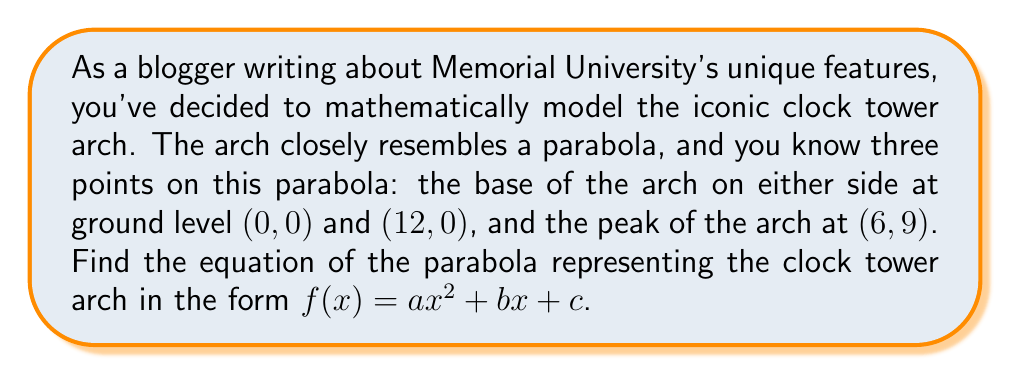Provide a solution to this math problem. To find the equation of the parabola, we'll follow these steps:

1) The general form of a parabola is $f(x) = ax^2 + bx + c$, where $a$, $b$, and $c$ are constants and $a \neq 0$.

2) We have three points: (0, 0), (12, 0), and (6, 9). Let's use these to create a system of equations:

   $f(0) = a(0)^2 + b(0) + c = 0$
   $f(12) = a(12)^2 + b(12) + c = 0$
   $f(6) = a(6)^2 + b(6) + c = 9$

3) From the first equation:
   $c = 0$

4) Substitute this into the other two equations:
   $144a + 12b = 0$
   $36a + 6b = 9$

5) Multiply the second equation by 2:
   $144a + 12b = 0$
   $72a + 12b = 18$

6) Subtract the second equation from the first:
   $72a = -18$
   $a = -\frac{1}{4}$

7) Substitute this back into $36a + 6b = 9$:
   $36(-\frac{1}{4}) + 6b = 9$
   $-9 + 6b = 9$
   $6b = 18$
   $b = 3$

8) Therefore, the equation of the parabola is:
   $f(x) = -\frac{1}{4}x^2 + 3x$

This parabola passes through (0, 0), (12, 0), and (6, 9), perfectly representing the arch of the Memorial University clock tower.
Answer: $f(x) = -\frac{1}{4}x^2 + 3x$ 